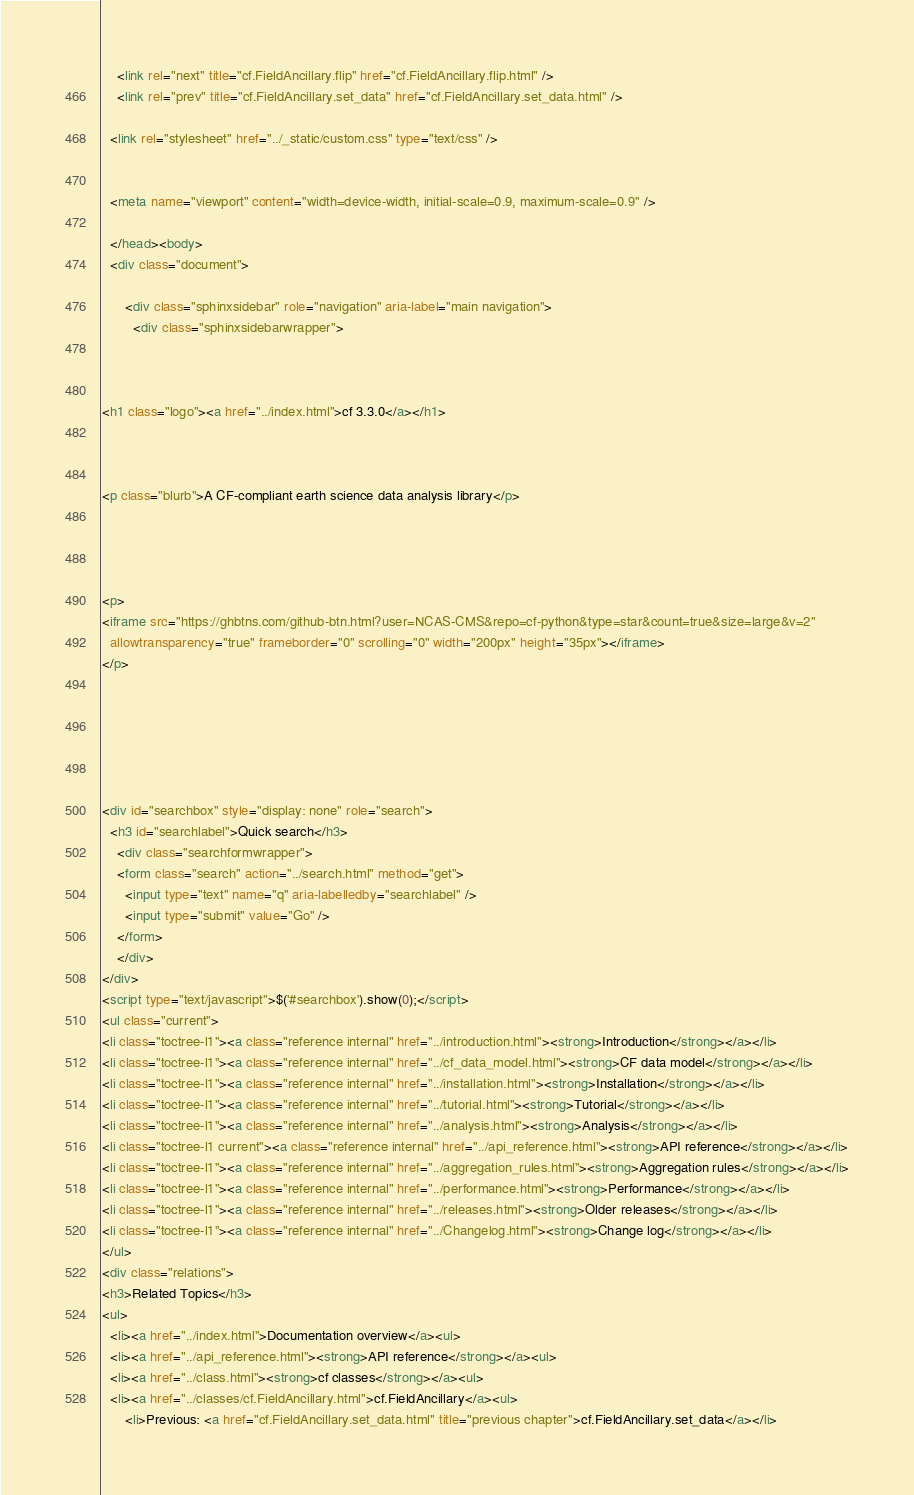<code> <loc_0><loc_0><loc_500><loc_500><_HTML_>    <link rel="next" title="cf.FieldAncillary.flip" href="cf.FieldAncillary.flip.html" />
    <link rel="prev" title="cf.FieldAncillary.set_data" href="cf.FieldAncillary.set_data.html" />
   
  <link rel="stylesheet" href="../_static/custom.css" type="text/css" />
  
  
  <meta name="viewport" content="width=device-width, initial-scale=0.9, maximum-scale=0.9" />

  </head><body>
  <div class="document">
    
      <div class="sphinxsidebar" role="navigation" aria-label="main navigation">
        <div class="sphinxsidebarwrapper">



<h1 class="logo"><a href="../index.html">cf 3.3.0</a></h1>



<p class="blurb">A CF-compliant earth science data analysis library</p>




<p>
<iframe src="https://ghbtns.com/github-btn.html?user=NCAS-CMS&repo=cf-python&type=star&count=true&size=large&v=2"
  allowtransparency="true" frameborder="0" scrolling="0" width="200px" height="35px"></iframe>
</p>






<div id="searchbox" style="display: none" role="search">
  <h3 id="searchlabel">Quick search</h3>
    <div class="searchformwrapper">
    <form class="search" action="../search.html" method="get">
      <input type="text" name="q" aria-labelledby="searchlabel" />
      <input type="submit" value="Go" />
    </form>
    </div>
</div>
<script type="text/javascript">$('#searchbox').show(0);</script>
<ul class="current">
<li class="toctree-l1"><a class="reference internal" href="../introduction.html"><strong>Introduction</strong></a></li>
<li class="toctree-l1"><a class="reference internal" href="../cf_data_model.html"><strong>CF data model</strong></a></li>
<li class="toctree-l1"><a class="reference internal" href="../installation.html"><strong>Installation</strong></a></li>
<li class="toctree-l1"><a class="reference internal" href="../tutorial.html"><strong>Tutorial</strong></a></li>
<li class="toctree-l1"><a class="reference internal" href="../analysis.html"><strong>Analysis</strong></a></li>
<li class="toctree-l1 current"><a class="reference internal" href="../api_reference.html"><strong>API reference</strong></a></li>
<li class="toctree-l1"><a class="reference internal" href="../aggregation_rules.html"><strong>Aggregation rules</strong></a></li>
<li class="toctree-l1"><a class="reference internal" href="../performance.html"><strong>Performance</strong></a></li>
<li class="toctree-l1"><a class="reference internal" href="../releases.html"><strong>Older releases</strong></a></li>
<li class="toctree-l1"><a class="reference internal" href="../Changelog.html"><strong>Change log</strong></a></li>
</ul>
<div class="relations">
<h3>Related Topics</h3>
<ul>
  <li><a href="../index.html">Documentation overview</a><ul>
  <li><a href="../api_reference.html"><strong>API reference</strong></a><ul>
  <li><a href="../class.html"><strong>cf classes</strong></a><ul>
  <li><a href="../classes/cf.FieldAncillary.html">cf.FieldAncillary</a><ul>
      <li>Previous: <a href="cf.FieldAncillary.set_data.html" title="previous chapter">cf.FieldAncillary.set_data</a></li></code> 